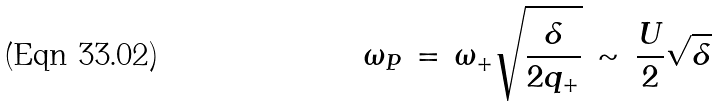Convert formula to latex. <formula><loc_0><loc_0><loc_500><loc_500>\omega _ { P } \, = \, \omega _ { + } \sqrt { \frac { \delta } { 2 q _ { + } } } \, \sim \, \frac { U } { 2 } \sqrt { \delta }</formula> 